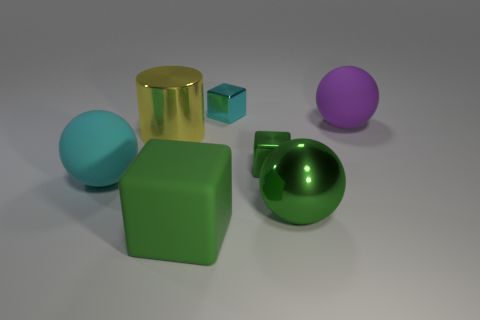Subtract 1 spheres. How many spheres are left? 2 Add 1 big purple matte things. How many objects exist? 8 Subtract all matte balls. How many balls are left? 1 Subtract all spheres. How many objects are left? 4 Subtract all big green rubber blocks. Subtract all large shiny cylinders. How many objects are left? 5 Add 2 big rubber balls. How many big rubber balls are left? 4 Add 2 large purple shiny cylinders. How many large purple shiny cylinders exist? 2 Subtract 0 purple cylinders. How many objects are left? 7 